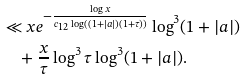<formula> <loc_0><loc_0><loc_500><loc_500>& \ll x e ^ { - \frac { \log x } { c _ { 1 2 } \log ( ( 1 + | a | ) ( 1 + \tau ) ) } } \log ^ { 3 } ( 1 + | a | ) \\ & \quad + \frac { x } { \tau } \log ^ { 3 } \tau \log ^ { 3 } ( 1 + | a | ) .</formula> 